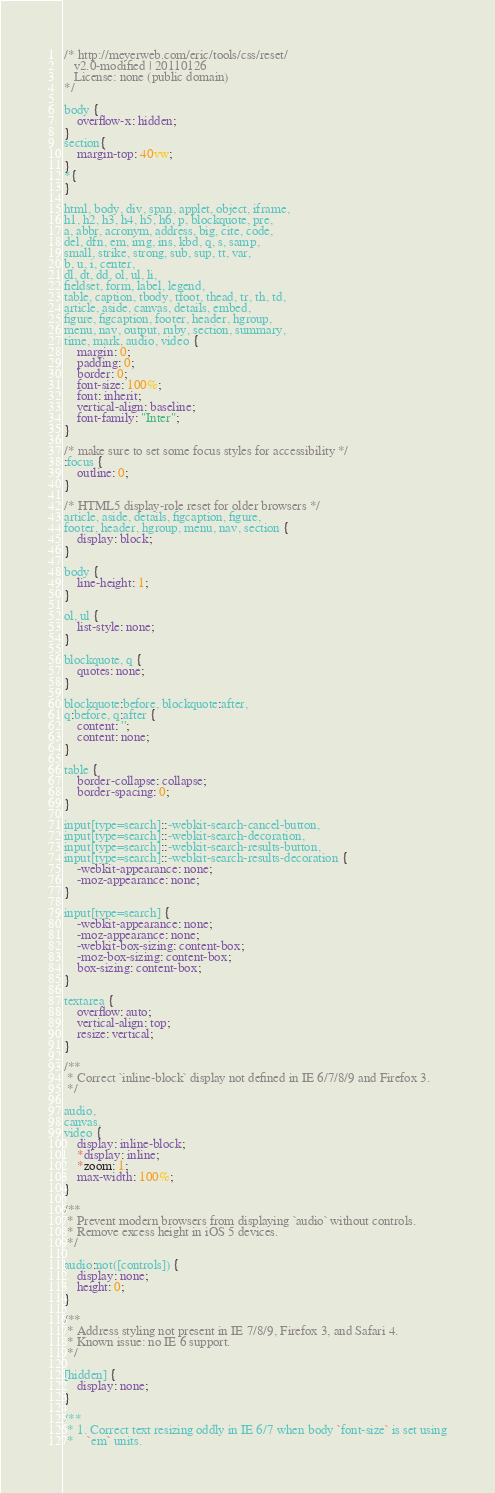<code> <loc_0><loc_0><loc_500><loc_500><_CSS_>/* http://meyerweb.com/eric/tools/css/reset/
   v2.0-modified | 20110126
   License: none (public domain)
*/

body {
    overflow-x: hidden;
}
section{
    margin-top: 40vw;
}
*{
}

html, body, div, span, applet, object, iframe,
h1, h2, h3, h4, h5, h6, p, blockquote, pre,
a, abbr, acronym, address, big, cite, code,
del, dfn, em, img, ins, kbd, q, s, samp,
small, strike, strong, sub, sup, tt, var,
b, u, i, center,
dl, dt, dd, ol, ul, li,
fieldset, form, label, legend,
table, caption, tbody, tfoot, thead, tr, th, td,
article, aside, canvas, details, embed,
figure, figcaption, footer, header, hgroup,
menu, nav, output, ruby, section, summary,
time, mark, audio, video {
    margin: 0;
	padding: 0;
	border: 0;
	font-size: 100%;
	font: inherit;
	vertical-align: baseline;
    font-family: "Inter";
}

/* make sure to set some focus styles for accessibility */
:focus {
    outline: 0;
}

/* HTML5 display-role reset for older browsers */
article, aside, details, figcaption, figure,
footer, header, hgroup, menu, nav, section {
	display: block;
}

body {
	line-height: 1;
}

ol, ul {
	list-style: none;
}

blockquote, q {
	quotes: none;
}

blockquote:before, blockquote:after,
q:before, q:after {
	content: '';
	content: none;
}

table {
	border-collapse: collapse;
	border-spacing: 0;
}

input[type=search]::-webkit-search-cancel-button,
input[type=search]::-webkit-search-decoration,
input[type=search]::-webkit-search-results-button,
input[type=search]::-webkit-search-results-decoration {
    -webkit-appearance: none;
    -moz-appearance: none;
}

input[type=search] {
    -webkit-appearance: none;
    -moz-appearance: none;
    -webkit-box-sizing: content-box;
    -moz-box-sizing: content-box;
    box-sizing: content-box;
}

textarea {
    overflow: auto;
    vertical-align: top;
    resize: vertical;
}

/**
 * Correct `inline-block` display not defined in IE 6/7/8/9 and Firefox 3.
 */

audio,
canvas,
video {
    display: inline-block;
    *display: inline;
    *zoom: 1;
    max-width: 100%;
}

/**
 * Prevent modern browsers from displaying `audio` without controls.
 * Remove excess height in iOS 5 devices.
 */

audio:not([controls]) {
    display: none;
    height: 0;
}

/**
 * Address styling not present in IE 7/8/9, Firefox 3, and Safari 4.
 * Known issue: no IE 6 support.
 */

[hidden] {
    display: none;
}

/**
 * 1. Correct text resizing oddly in IE 6/7 when body `font-size` is set using
 *    `em` units.</code> 